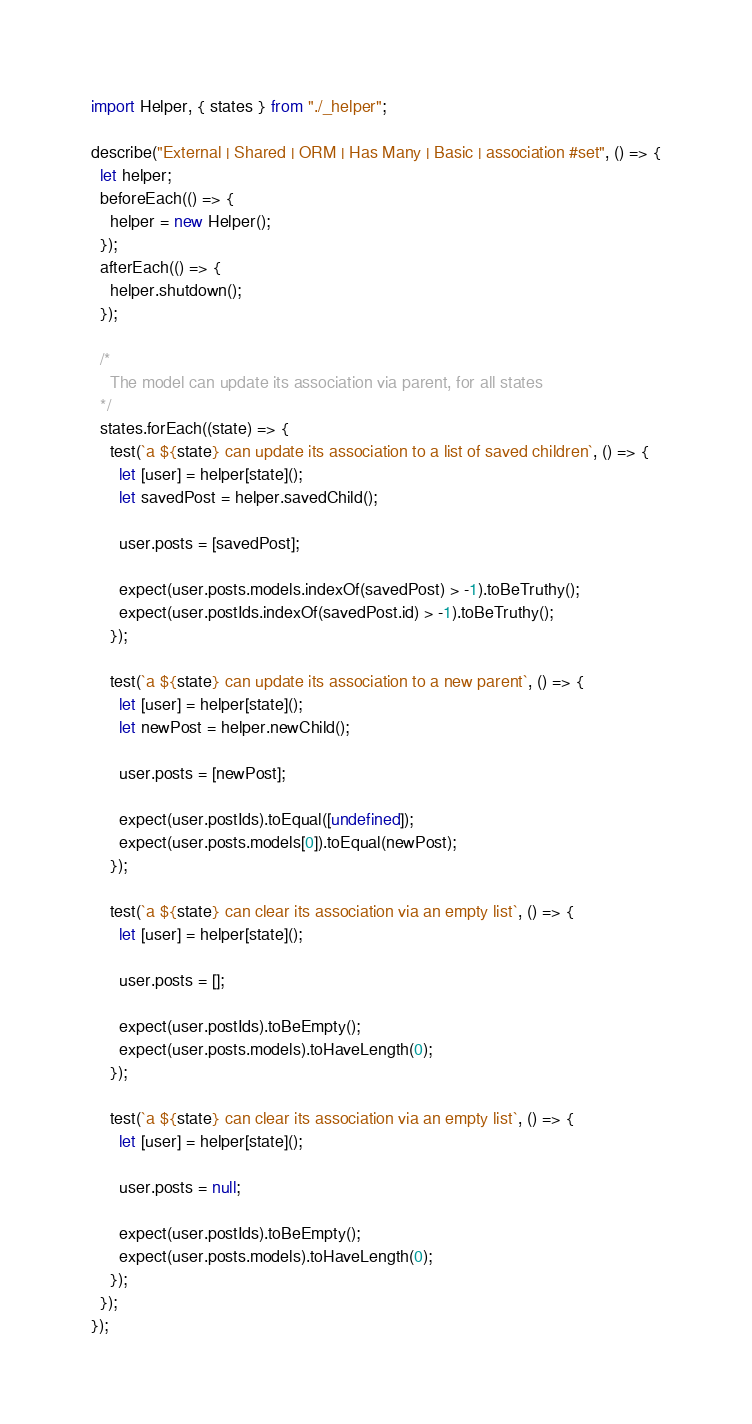<code> <loc_0><loc_0><loc_500><loc_500><_JavaScript_>import Helper, { states } from "./_helper";

describe("External | Shared | ORM | Has Many | Basic | association #set", () => {
  let helper;
  beforeEach(() => {
    helper = new Helper();
  });
  afterEach(() => {
    helper.shutdown();
  });

  /*
    The model can update its association via parent, for all states
  */
  states.forEach((state) => {
    test(`a ${state} can update its association to a list of saved children`, () => {
      let [user] = helper[state]();
      let savedPost = helper.savedChild();

      user.posts = [savedPost];

      expect(user.posts.models.indexOf(savedPost) > -1).toBeTruthy();
      expect(user.postIds.indexOf(savedPost.id) > -1).toBeTruthy();
    });

    test(`a ${state} can update its association to a new parent`, () => {
      let [user] = helper[state]();
      let newPost = helper.newChild();

      user.posts = [newPost];

      expect(user.postIds).toEqual([undefined]);
      expect(user.posts.models[0]).toEqual(newPost);
    });

    test(`a ${state} can clear its association via an empty list`, () => {
      let [user] = helper[state]();

      user.posts = [];

      expect(user.postIds).toBeEmpty();
      expect(user.posts.models).toHaveLength(0);
    });

    test(`a ${state} can clear its association via an empty list`, () => {
      let [user] = helper[state]();

      user.posts = null;

      expect(user.postIds).toBeEmpty();
      expect(user.posts.models).toHaveLength(0);
    });
  });
});
</code> 